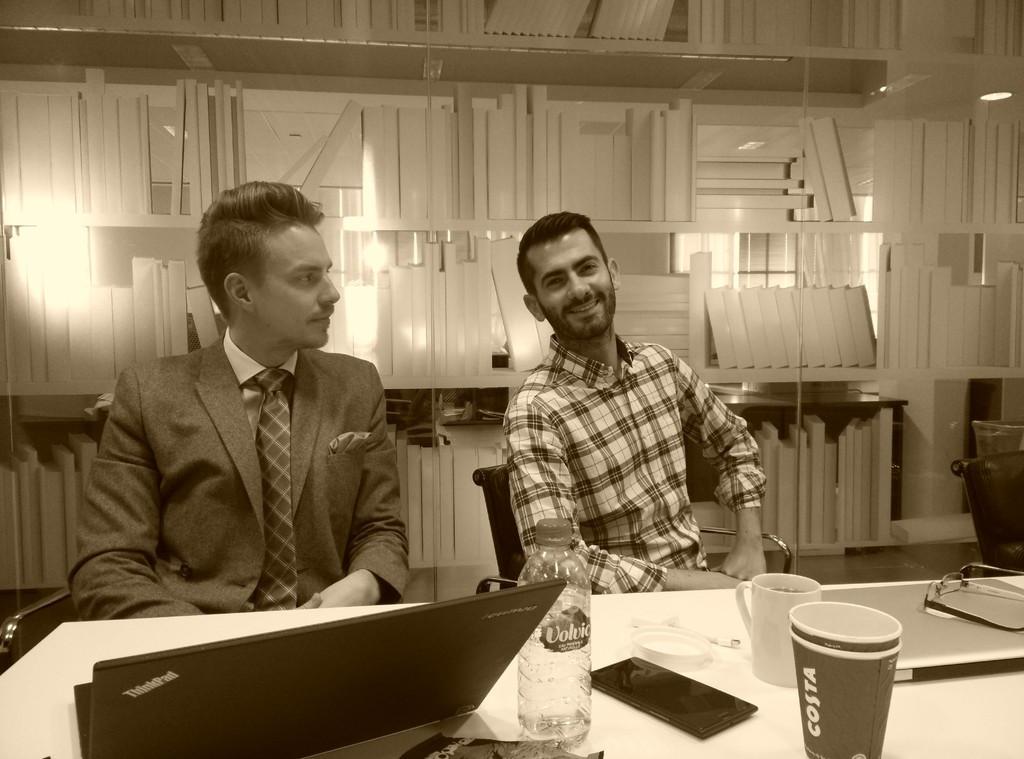Can you describe this image briefly? This picture shows that there are two men, sitting in the chairs in front of a table. On the table there is a laptop, bottle, mobile and some glasses here. In the background there is a wall made up of some design. 